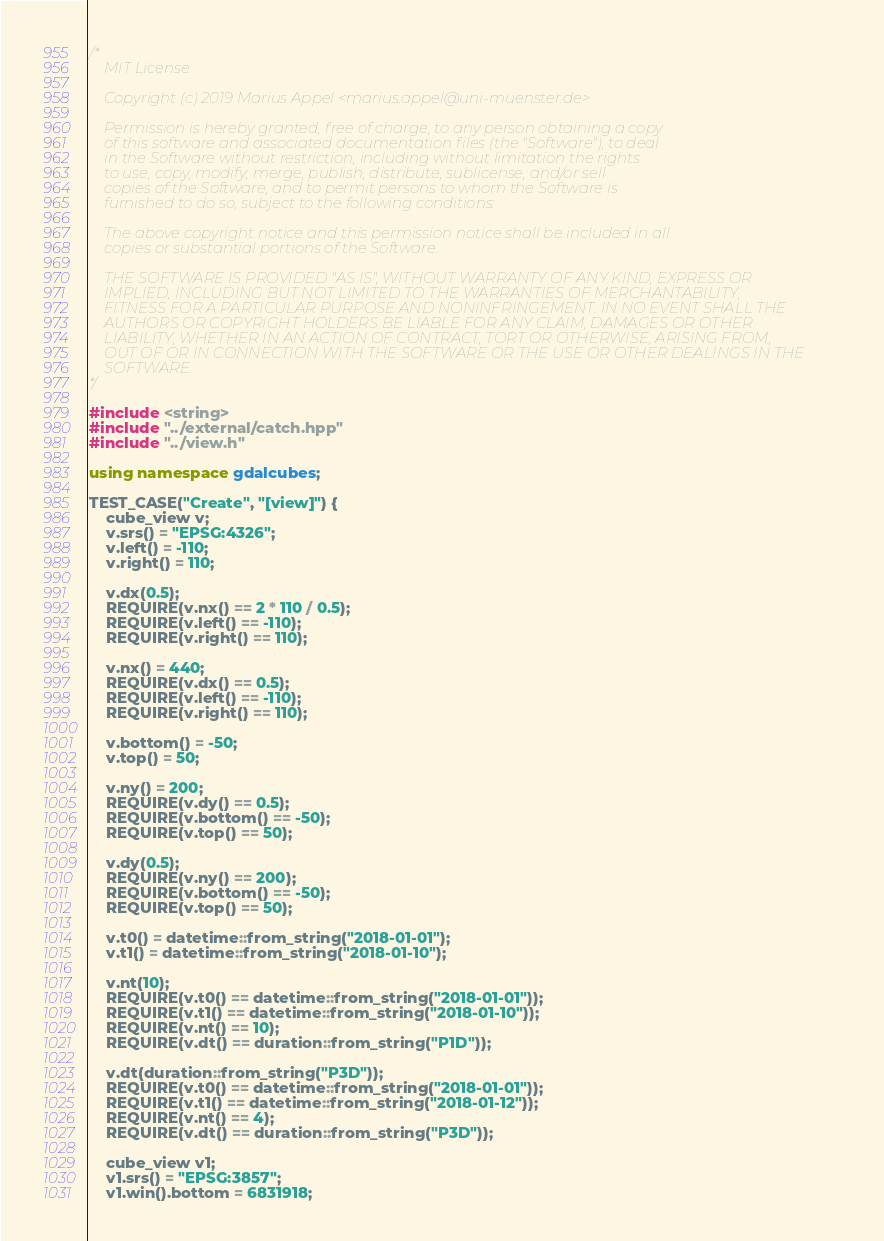<code> <loc_0><loc_0><loc_500><loc_500><_C++_>/*
    MIT License

    Copyright (c) 2019 Marius Appel <marius.appel@uni-muenster.de>

    Permission is hereby granted, free of charge, to any person obtaining a copy
    of this software and associated documentation files (the "Software"), to deal
    in the Software without restriction, including without limitation the rights
    to use, copy, modify, merge, publish, distribute, sublicense, and/or sell
    copies of the Software, and to permit persons to whom the Software is
    furnished to do so, subject to the following conditions:

    The above copyright notice and this permission notice shall be included in all
    copies or substantial portions of the Software.

    THE SOFTWARE IS PROVIDED "AS IS", WITHOUT WARRANTY OF ANY KIND, EXPRESS OR
    IMPLIED, INCLUDING BUT NOT LIMITED TO THE WARRANTIES OF MERCHANTABILITY,
    FITNESS FOR A PARTICULAR PURPOSE AND NONINFRINGEMENT. IN NO EVENT SHALL THE
    AUTHORS OR COPYRIGHT HOLDERS BE LIABLE FOR ANY CLAIM, DAMAGES OR OTHER
    LIABILITY, WHETHER IN AN ACTION OF CONTRACT, TORT OR OTHERWISE, ARISING FROM,
    OUT OF OR IN CONNECTION WITH THE SOFTWARE OR THE USE OR OTHER DEALINGS IN THE
    SOFTWARE.
*/

#include <string>
#include "../external/catch.hpp"
#include "../view.h"

using namespace gdalcubes;

TEST_CASE("Create", "[view]") {
    cube_view v;
    v.srs() = "EPSG:4326";
    v.left() = -110;
    v.right() = 110;

    v.dx(0.5);
    REQUIRE(v.nx() == 2 * 110 / 0.5);
    REQUIRE(v.left() == -110);
    REQUIRE(v.right() == 110);

    v.nx() = 440;
    REQUIRE(v.dx() == 0.5);
    REQUIRE(v.left() == -110);
    REQUIRE(v.right() == 110);

    v.bottom() = -50;
    v.top() = 50;

    v.ny() = 200;
    REQUIRE(v.dy() == 0.5);
    REQUIRE(v.bottom() == -50);
    REQUIRE(v.top() == 50);

    v.dy(0.5);
    REQUIRE(v.ny() == 200);
    REQUIRE(v.bottom() == -50);
    REQUIRE(v.top() == 50);

    v.t0() = datetime::from_string("2018-01-01");
    v.t1() = datetime::from_string("2018-01-10");

    v.nt(10);
    REQUIRE(v.t0() == datetime::from_string("2018-01-01"));
    REQUIRE(v.t1() == datetime::from_string("2018-01-10"));
    REQUIRE(v.nt() == 10);
    REQUIRE(v.dt() == duration::from_string("P1D"));

    v.dt(duration::from_string("P3D"));
    REQUIRE(v.t0() == datetime::from_string("2018-01-01"));
    REQUIRE(v.t1() == datetime::from_string("2018-01-12"));
    REQUIRE(v.nt() == 4);
    REQUIRE(v.dt() == duration::from_string("P3D"));

    cube_view v1;
    v1.srs() = "EPSG:3857";
    v1.win().bottom = 6831918;</code> 